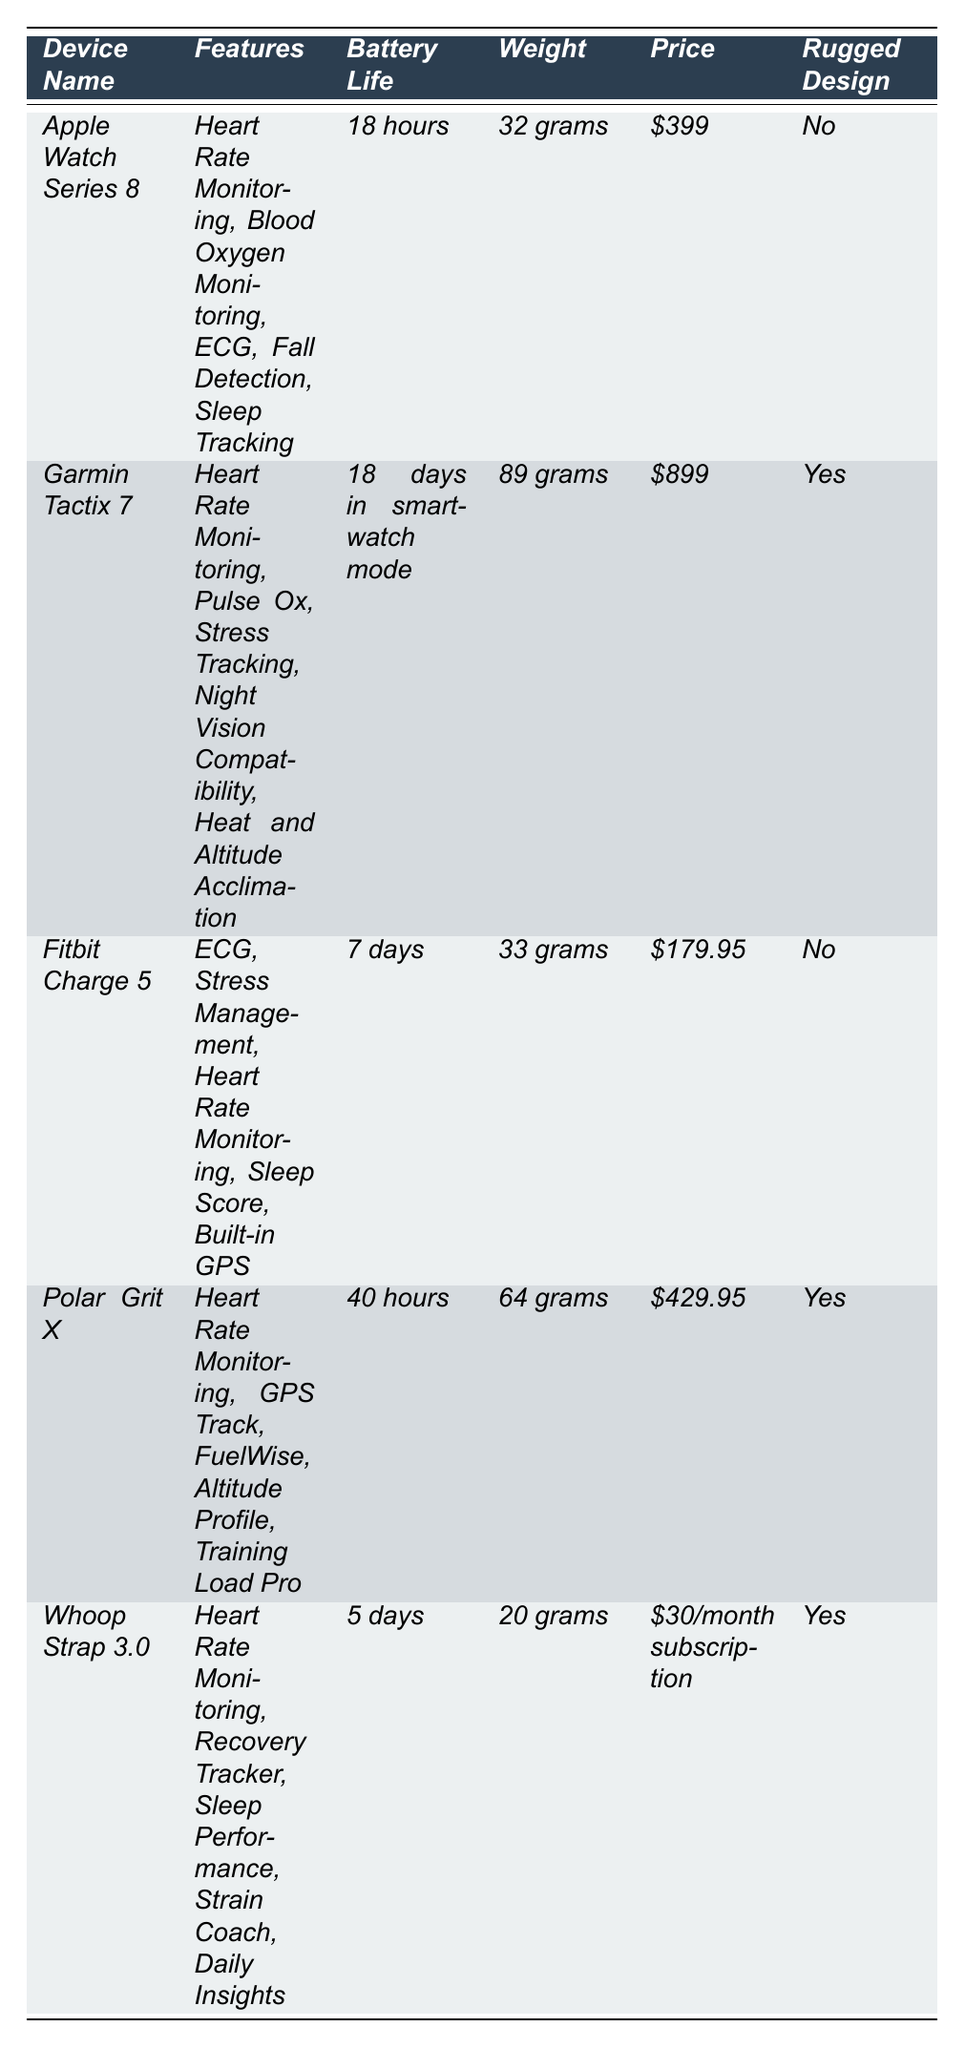What is the weight of the Apple Watch Series 8? The table lists the weight of the Apple Watch Series 8 under the "Weight" column, which states it's 32 grams.
Answer: 32 grams Which device has the longest battery life? By comparing the "Battery Life" values in the table, the Garmin Tactix 7 has 18 days in smartwatch mode, which is longer than the battery lives of all other devices listed.
Answer: Garmin Tactix 7 How much does the Whoop Strap 3.0 cost per month? The "Price" column specifies that the Whoop Strap 3.0 costs $30 per month as a subscription.
Answer: $30/month Does the Fitbit Charge 5 have a rugged design? The "Rugged Design" column indicates that the Fitbit Charge 5 is marked as "No," meaning it does not have a rugged design.
Answer: No What is the average weight of the devices listed? The weights are 32 grams, 89 grams, 33 grams, 64 grams, and 20 grams. Calculating the average involves summing these values (32 + 89 + 33 + 64 + 20 = 238 grams) and dividing by the count (5 devices). Average weight = 238/5 = 47.6 grams.
Answer: 47.6 grams Which devices offer heart rate monitoring as a feature? By examining the "Features" column, heart rate monitoring is found in the Apple Watch Series 8, Garmin Tactix 7, Fitbit Charge 5, Polar Grit X, and Whoop Strap 3.0.
Answer: All devices (5 devices) Is the price of the Polar Grit X higher or lower than the Apple Watch Series 8? Comparing the values in the "Price" column, the Polar Grit X is listed at $429.95, while the Apple Watch Series 8 costs $399. Since $429.95 is higher than $399, the Polar Grit X is more expensive.
Answer: Higher Which device is the lightest among those listed? The weights provided in the table are compared. The lightest device is the Whoop Strap 3.0 at 20 grams.
Answer: Whoop Strap 3.0 If a soldier is looking for a device with ECG and rugged design, which devices can they select? The devices with ECG listed are the Apple Watch Series 8, Fitbit Charge 5, and Whoop Strap 3.0; however, only the Whoop Strap 3.0 and Garmin Tactix 7 have a rugged design. The only device that meets both criteria is the Whoop Strap 3.0.
Answer: Whoop Strap 3.0 What is the total price of all the devices, excluding the Whoop Strap 3.0 subscription? The prices to sum are: Apple Watch Series 8 at $399, Garmin Tactix 7 at $899, Fitbit Charge 5 at $179.95, and Polar Grit X at $429.95. Sum = $399 + $899 + $179.95 + $429.95 = $1908.90.
Answer: $1908.90 